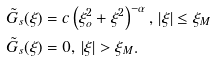Convert formula to latex. <formula><loc_0><loc_0><loc_500><loc_500>\tilde { G } _ { s } ( \xi ) & = c \left ( \xi _ { o } ^ { 2 } + \xi ^ { 2 } \right ) ^ { - \alpha } , \, \left | \xi \right | \leq \xi _ { M } \\ \tilde { G } _ { s } ( \xi ) & = 0 , \, \left | \xi \right | > \xi _ { M } .</formula> 